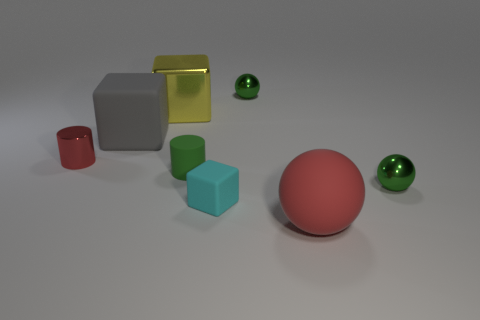There is a cyan thing that is the same size as the green cylinder; what shape is it?
Offer a terse response. Cube. What number of objects are large green cubes or green metal balls that are in front of the large yellow metallic object?
Your answer should be compact. 1. Is the material of the small ball that is behind the small red thing the same as the red thing in front of the green rubber thing?
Ensure brevity in your answer.  No. There is a thing that is the same color as the big rubber ball; what shape is it?
Provide a succinct answer. Cylinder. How many blue objects are blocks or small blocks?
Provide a short and direct response. 0. What is the size of the cyan rubber object?
Provide a succinct answer. Small. Are there more small cyan things that are on the right side of the tiny cyan object than red metal objects?
Your response must be concise. No. There is a yellow shiny thing; how many tiny cyan rubber things are in front of it?
Provide a succinct answer. 1. Is there a red cylinder that has the same size as the yellow shiny thing?
Make the answer very short. No. There is a large shiny thing that is the same shape as the cyan rubber thing; what is its color?
Give a very brief answer. Yellow. 